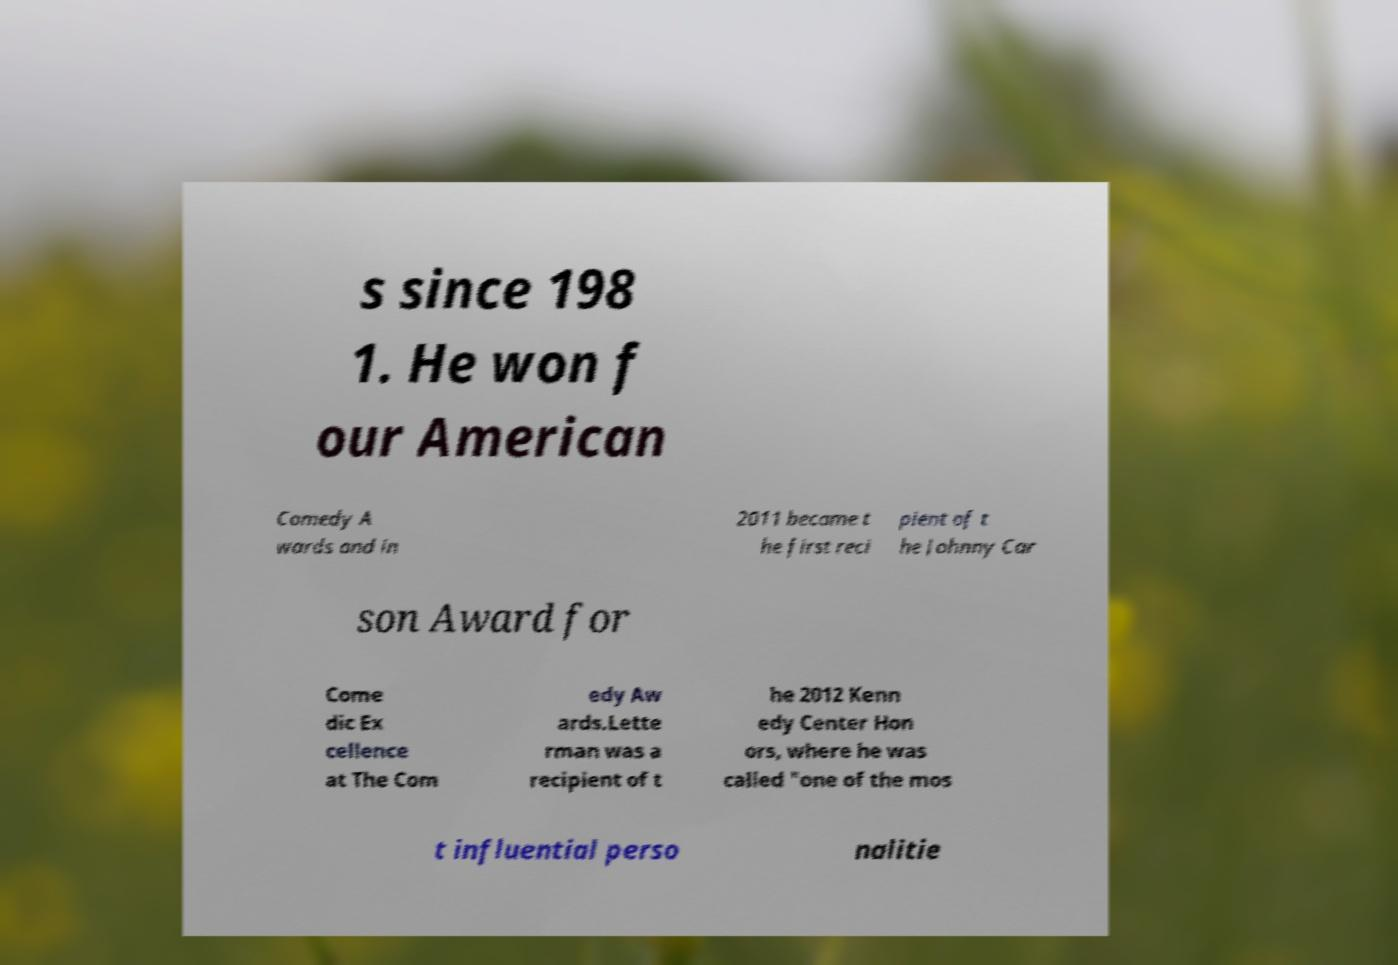Could you assist in decoding the text presented in this image and type it out clearly? s since 198 1. He won f our American Comedy A wards and in 2011 became t he first reci pient of t he Johnny Car son Award for Come dic Ex cellence at The Com edy Aw ards.Lette rman was a recipient of t he 2012 Kenn edy Center Hon ors, where he was called "one of the mos t influential perso nalitie 